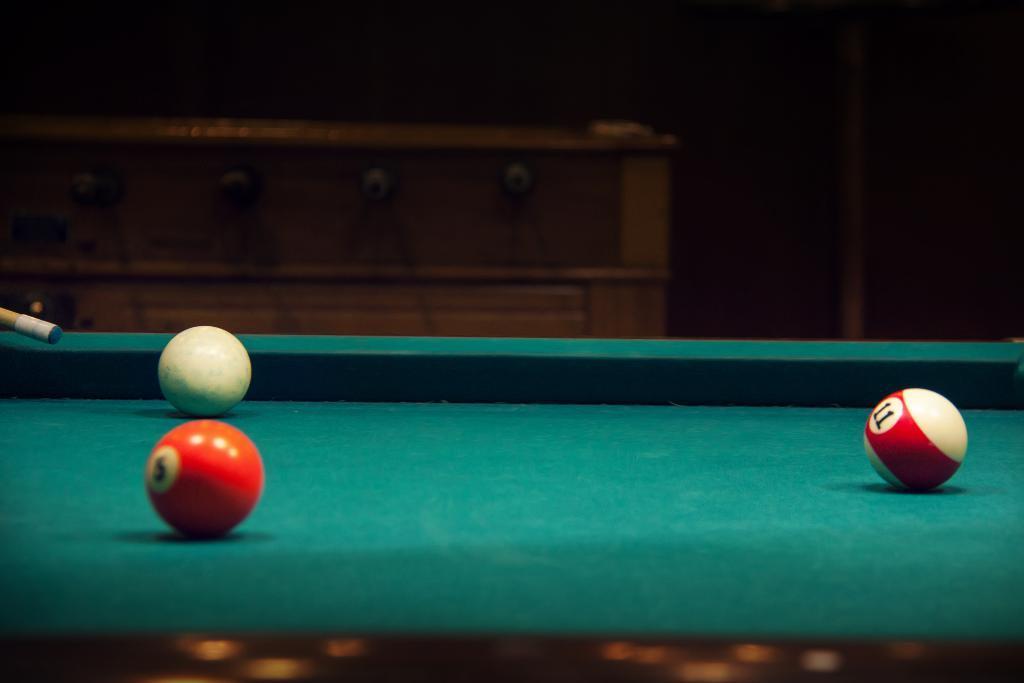Describe this image in one or two sentences. This is a picture where we have a snooker board, and 3 snooker balls and a snooker stick. 